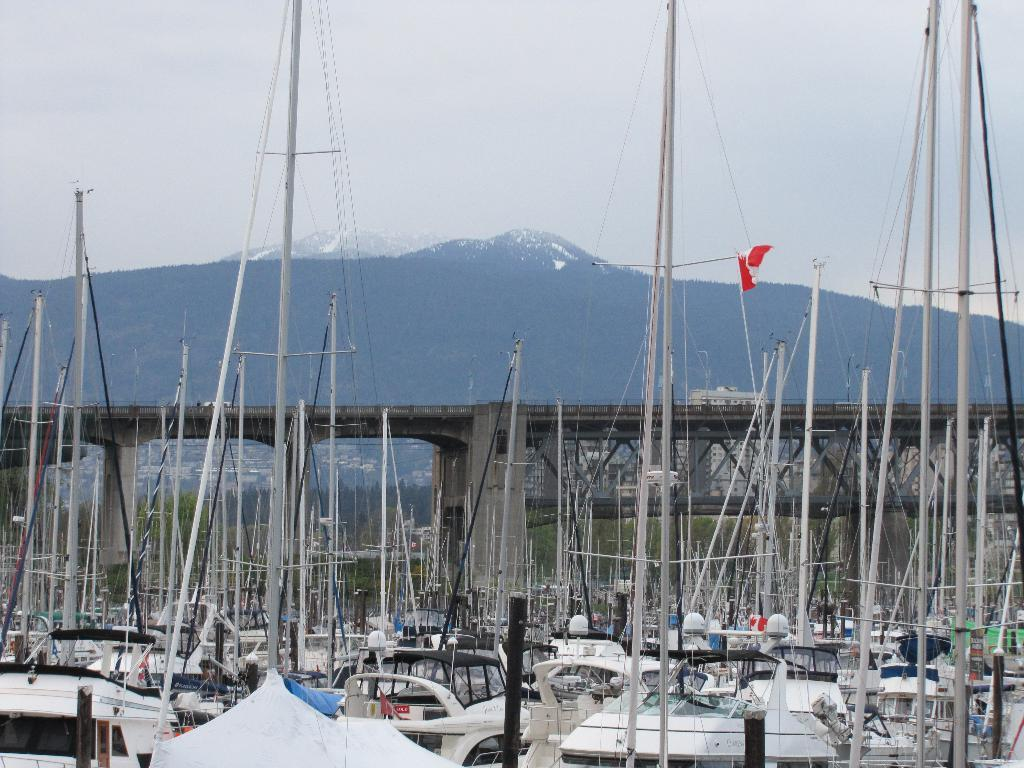What can be seen in the image that is used for transportation on water? There are boats in the image. What structure is present in the image that allows people to cross over a body of water? There is a bridge in the image. What colors are present on the flag in the image? The flag in the image has colors white and red. What type of natural landform can be seen in the background of the image? There are mountains in the background of the image. What is visible in the sky in the background of the image? The sky is visible in the background of the image. How many eggs can be seen in the image? There are no eggs present in the image. Are there any bears visible in the image? There are no bears present in the image. 